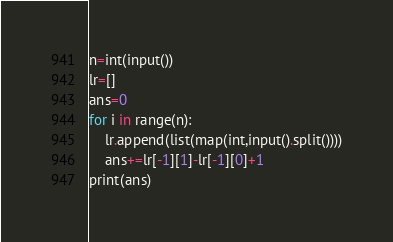Convert code to text. <code><loc_0><loc_0><loc_500><loc_500><_Python_>n=int(input())
lr=[]
ans=0
for i in range(n):
    lr.append(list(map(int,input().split())))
    ans+=lr[-1][1]-lr[-1][0]+1
print(ans)</code> 